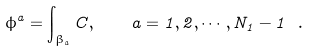<formula> <loc_0><loc_0><loc_500><loc_500>\phi ^ { a } = \int _ { \beta _ { a } } C , \quad a = 1 , 2 , \cdots , N _ { 1 } - 1 \ .</formula> 